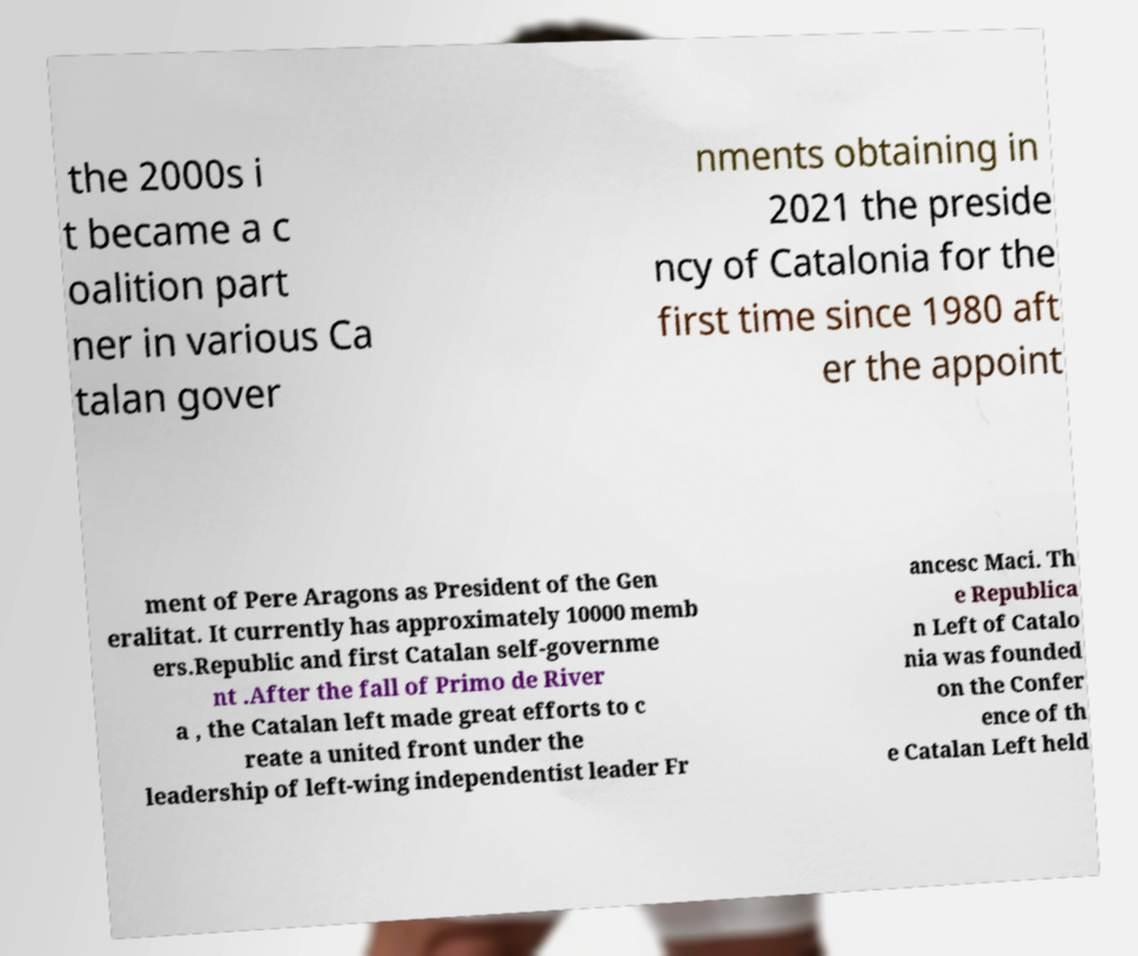I need the written content from this picture converted into text. Can you do that? the 2000s i t became a c oalition part ner in various Ca talan gover nments obtaining in 2021 the preside ncy of Catalonia for the first time since 1980 aft er the appoint ment of Pere Aragons as President of the Gen eralitat. It currently has approximately 10000 memb ers.Republic and first Catalan self-governme nt .After the fall of Primo de River a , the Catalan left made great efforts to c reate a united front under the leadership of left-wing independentist leader Fr ancesc Maci. Th e Republica n Left of Catalo nia was founded on the Confer ence of th e Catalan Left held 